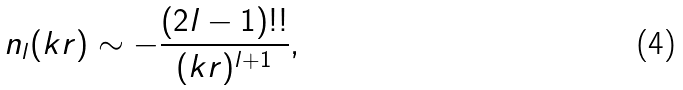<formula> <loc_0><loc_0><loc_500><loc_500>n _ { l } ( k r ) \sim - \frac { ( 2 l - 1 ) ! ! } { ( k r ) ^ { l + 1 } } ,</formula> 